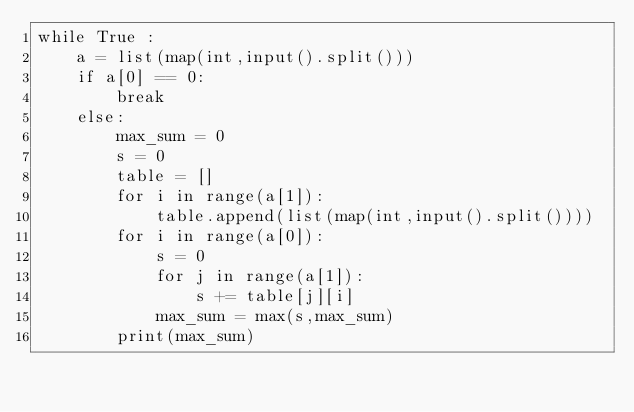<code> <loc_0><loc_0><loc_500><loc_500><_Python_>while True :
    a = list(map(int,input().split()))
    if a[0] == 0:
        break
    else:
        max_sum = 0
        s = 0
        table = []
        for i in range(a[1]):
            table.append(list(map(int,input().split())))
        for i in range(a[0]):
            s = 0
            for j in range(a[1]):
                s += table[j][i]
            max_sum = max(s,max_sum)
        print(max_sum)
</code> 